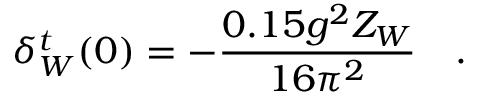<formula> <loc_0><loc_0><loc_500><loc_500>\delta _ { W } ^ { t } ( 0 ) = - { \frac { 0 . 1 5 g ^ { 2 } Z _ { W } } { 1 6 \pi ^ { 2 } } } .</formula> 